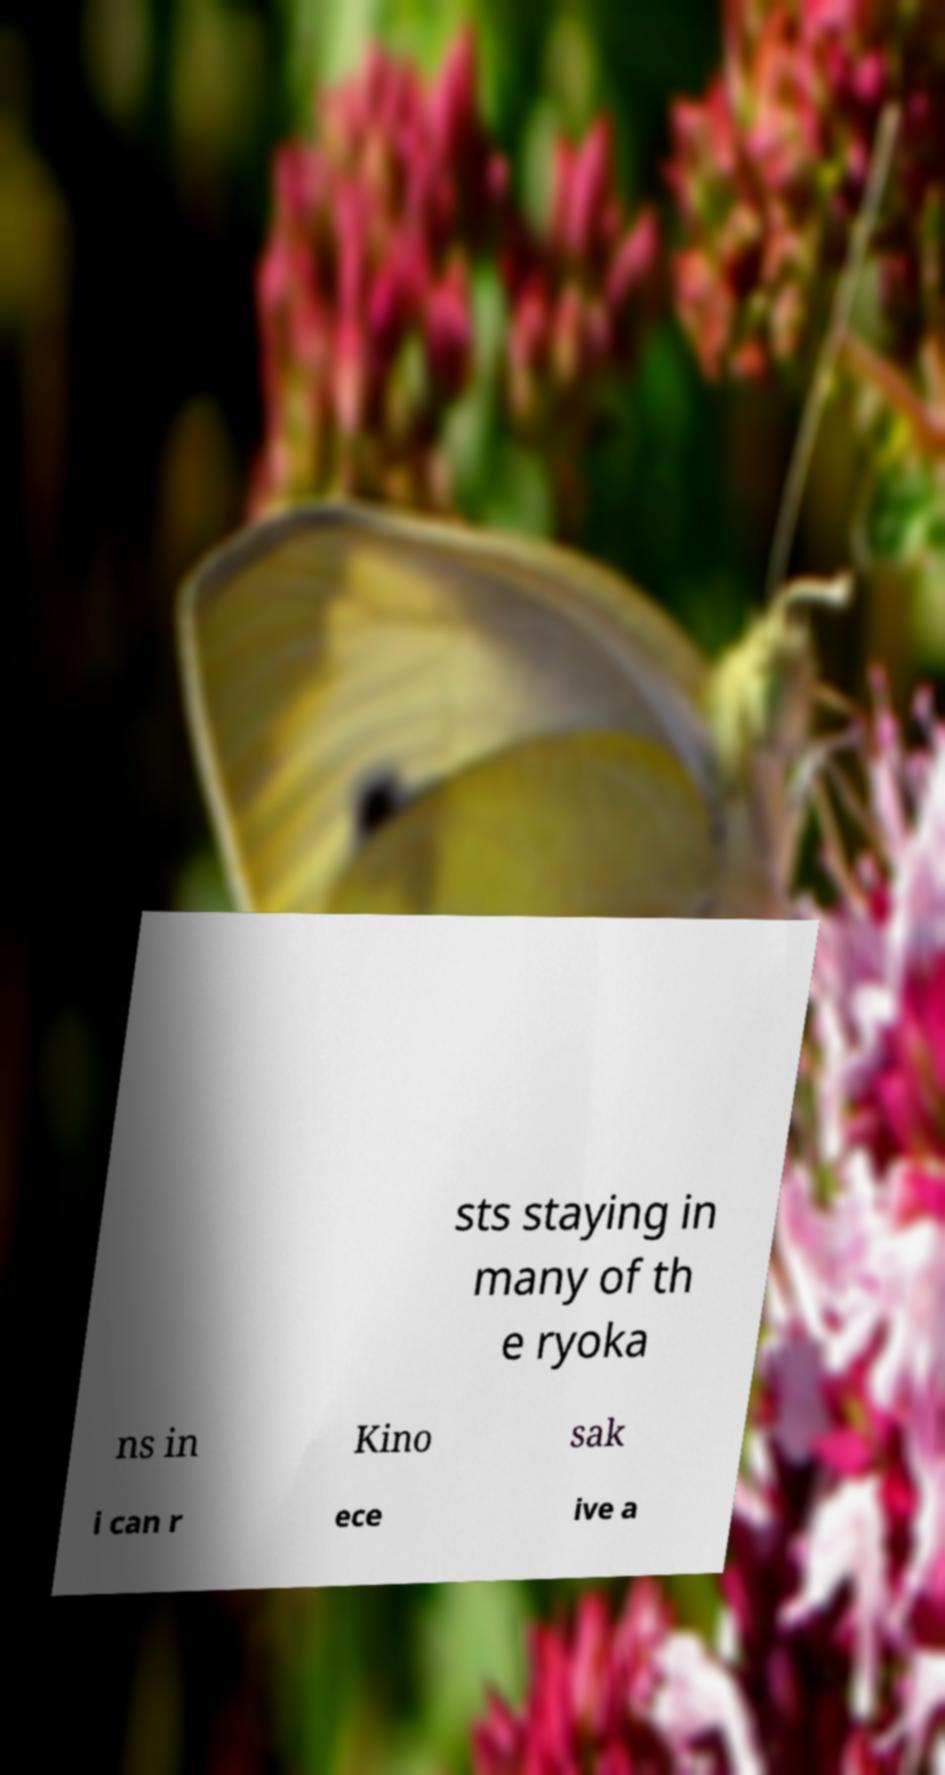Please read and relay the text visible in this image. What does it say? sts staying in many of th e ryoka ns in Kino sak i can r ece ive a 